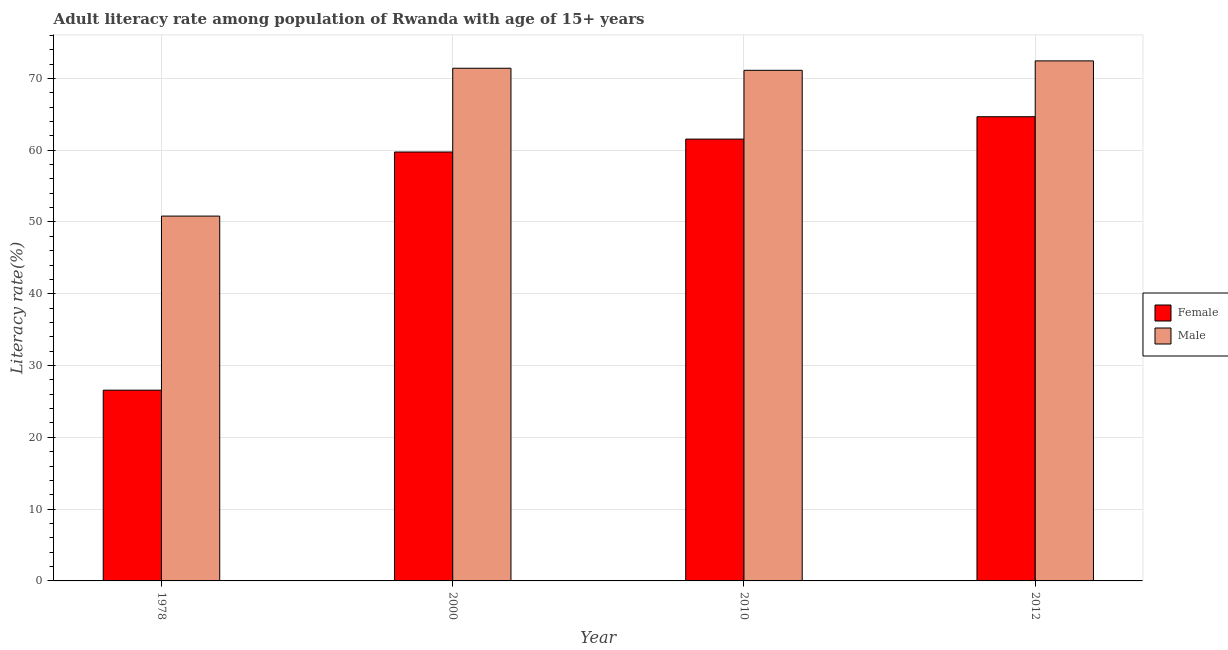How many different coloured bars are there?
Provide a short and direct response. 2. How many groups of bars are there?
Your answer should be very brief. 4. Are the number of bars per tick equal to the number of legend labels?
Keep it short and to the point. Yes. Are the number of bars on each tick of the X-axis equal?
Your answer should be very brief. Yes. How many bars are there on the 1st tick from the left?
Offer a terse response. 2. How many bars are there on the 2nd tick from the right?
Offer a terse response. 2. What is the female adult literacy rate in 2000?
Offer a terse response. 59.75. Across all years, what is the maximum female adult literacy rate?
Provide a short and direct response. 64.66. Across all years, what is the minimum female adult literacy rate?
Provide a short and direct response. 26.57. In which year was the female adult literacy rate maximum?
Ensure brevity in your answer.  2012. In which year was the male adult literacy rate minimum?
Give a very brief answer. 1978. What is the total female adult literacy rate in the graph?
Provide a short and direct response. 212.54. What is the difference between the female adult literacy rate in 2010 and that in 2012?
Keep it short and to the point. -3.12. What is the difference between the male adult literacy rate in 1978 and the female adult literacy rate in 2012?
Give a very brief answer. -21.62. What is the average female adult literacy rate per year?
Provide a short and direct response. 53.13. In how many years, is the male adult literacy rate greater than 56 %?
Provide a succinct answer. 3. What is the ratio of the male adult literacy rate in 1978 to that in 2012?
Give a very brief answer. 0.7. Is the male adult literacy rate in 2000 less than that in 2012?
Offer a very short reply. Yes. What is the difference between the highest and the second highest female adult literacy rate?
Your answer should be very brief. 3.12. What is the difference between the highest and the lowest female adult literacy rate?
Make the answer very short. 38.09. What does the 1st bar from the left in 2012 represents?
Your response must be concise. Female. What does the 2nd bar from the right in 1978 represents?
Offer a terse response. Female. How many bars are there?
Make the answer very short. 8. Are all the bars in the graph horizontal?
Provide a succinct answer. No. How many years are there in the graph?
Make the answer very short. 4. Does the graph contain any zero values?
Your answer should be very brief. No. Does the graph contain grids?
Make the answer very short. Yes. Where does the legend appear in the graph?
Give a very brief answer. Center right. How many legend labels are there?
Keep it short and to the point. 2. What is the title of the graph?
Offer a terse response. Adult literacy rate among population of Rwanda with age of 15+ years. Does "GDP per capita" appear as one of the legend labels in the graph?
Your response must be concise. No. What is the label or title of the Y-axis?
Your response must be concise. Literacy rate(%). What is the Literacy rate(%) of Female in 1978?
Provide a succinct answer. 26.57. What is the Literacy rate(%) in Male in 1978?
Your answer should be compact. 50.82. What is the Literacy rate(%) in Female in 2000?
Provide a short and direct response. 59.75. What is the Literacy rate(%) of Male in 2000?
Offer a very short reply. 71.42. What is the Literacy rate(%) in Female in 2010?
Your response must be concise. 61.55. What is the Literacy rate(%) of Male in 2010?
Offer a very short reply. 71.13. What is the Literacy rate(%) in Female in 2012?
Your answer should be compact. 64.66. What is the Literacy rate(%) in Male in 2012?
Your response must be concise. 72.45. Across all years, what is the maximum Literacy rate(%) in Female?
Your answer should be compact. 64.66. Across all years, what is the maximum Literacy rate(%) of Male?
Provide a short and direct response. 72.45. Across all years, what is the minimum Literacy rate(%) of Female?
Offer a terse response. 26.57. Across all years, what is the minimum Literacy rate(%) in Male?
Provide a succinct answer. 50.82. What is the total Literacy rate(%) of Female in the graph?
Your answer should be compact. 212.54. What is the total Literacy rate(%) of Male in the graph?
Provide a succinct answer. 265.82. What is the difference between the Literacy rate(%) of Female in 1978 and that in 2000?
Offer a very short reply. -33.18. What is the difference between the Literacy rate(%) of Male in 1978 and that in 2000?
Provide a short and direct response. -20.6. What is the difference between the Literacy rate(%) of Female in 1978 and that in 2010?
Offer a terse response. -34.98. What is the difference between the Literacy rate(%) in Male in 1978 and that in 2010?
Give a very brief answer. -20.31. What is the difference between the Literacy rate(%) of Female in 1978 and that in 2012?
Keep it short and to the point. -38.09. What is the difference between the Literacy rate(%) of Male in 1978 and that in 2012?
Make the answer very short. -21.62. What is the difference between the Literacy rate(%) of Female in 2000 and that in 2010?
Your answer should be compact. -1.8. What is the difference between the Literacy rate(%) of Male in 2000 and that in 2010?
Provide a succinct answer. 0.29. What is the difference between the Literacy rate(%) in Female in 2000 and that in 2012?
Your answer should be very brief. -4.91. What is the difference between the Literacy rate(%) of Male in 2000 and that in 2012?
Ensure brevity in your answer.  -1.03. What is the difference between the Literacy rate(%) of Female in 2010 and that in 2012?
Offer a terse response. -3.12. What is the difference between the Literacy rate(%) of Male in 2010 and that in 2012?
Make the answer very short. -1.31. What is the difference between the Literacy rate(%) in Female in 1978 and the Literacy rate(%) in Male in 2000?
Offer a very short reply. -44.85. What is the difference between the Literacy rate(%) in Female in 1978 and the Literacy rate(%) in Male in 2010?
Keep it short and to the point. -44.56. What is the difference between the Literacy rate(%) in Female in 1978 and the Literacy rate(%) in Male in 2012?
Your answer should be compact. -45.87. What is the difference between the Literacy rate(%) in Female in 2000 and the Literacy rate(%) in Male in 2010?
Give a very brief answer. -11.38. What is the difference between the Literacy rate(%) of Female in 2000 and the Literacy rate(%) of Male in 2012?
Offer a terse response. -12.69. What is the difference between the Literacy rate(%) of Female in 2010 and the Literacy rate(%) of Male in 2012?
Your answer should be very brief. -10.9. What is the average Literacy rate(%) in Female per year?
Your answer should be compact. 53.13. What is the average Literacy rate(%) of Male per year?
Offer a very short reply. 66.45. In the year 1978, what is the difference between the Literacy rate(%) in Female and Literacy rate(%) in Male?
Offer a very short reply. -24.25. In the year 2000, what is the difference between the Literacy rate(%) in Female and Literacy rate(%) in Male?
Give a very brief answer. -11.67. In the year 2010, what is the difference between the Literacy rate(%) of Female and Literacy rate(%) of Male?
Provide a succinct answer. -9.58. In the year 2012, what is the difference between the Literacy rate(%) of Female and Literacy rate(%) of Male?
Offer a terse response. -7.78. What is the ratio of the Literacy rate(%) of Female in 1978 to that in 2000?
Your response must be concise. 0.44. What is the ratio of the Literacy rate(%) of Male in 1978 to that in 2000?
Offer a very short reply. 0.71. What is the ratio of the Literacy rate(%) in Female in 1978 to that in 2010?
Your response must be concise. 0.43. What is the ratio of the Literacy rate(%) of Male in 1978 to that in 2010?
Make the answer very short. 0.71. What is the ratio of the Literacy rate(%) in Female in 1978 to that in 2012?
Ensure brevity in your answer.  0.41. What is the ratio of the Literacy rate(%) of Male in 1978 to that in 2012?
Offer a terse response. 0.7. What is the ratio of the Literacy rate(%) of Female in 2000 to that in 2010?
Your response must be concise. 0.97. What is the ratio of the Literacy rate(%) in Male in 2000 to that in 2010?
Provide a short and direct response. 1. What is the ratio of the Literacy rate(%) in Female in 2000 to that in 2012?
Offer a terse response. 0.92. What is the ratio of the Literacy rate(%) of Male in 2000 to that in 2012?
Your answer should be compact. 0.99. What is the ratio of the Literacy rate(%) in Female in 2010 to that in 2012?
Keep it short and to the point. 0.95. What is the ratio of the Literacy rate(%) of Male in 2010 to that in 2012?
Your answer should be very brief. 0.98. What is the difference between the highest and the second highest Literacy rate(%) of Female?
Your response must be concise. 3.12. What is the difference between the highest and the second highest Literacy rate(%) in Male?
Provide a succinct answer. 1.03. What is the difference between the highest and the lowest Literacy rate(%) in Female?
Your answer should be very brief. 38.09. What is the difference between the highest and the lowest Literacy rate(%) of Male?
Your response must be concise. 21.62. 